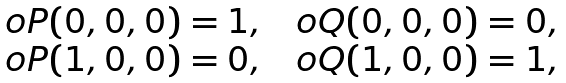<formula> <loc_0><loc_0><loc_500><loc_500>\begin{array} { c c c } o { P } ( 0 , 0 , 0 ) = 1 , & & o { Q } ( 0 , 0 , 0 ) = 0 , \\ o { P } ( 1 , 0 , 0 ) = 0 , & & o { Q } ( 1 , 0 , 0 ) = 1 , \end{array}</formula> 